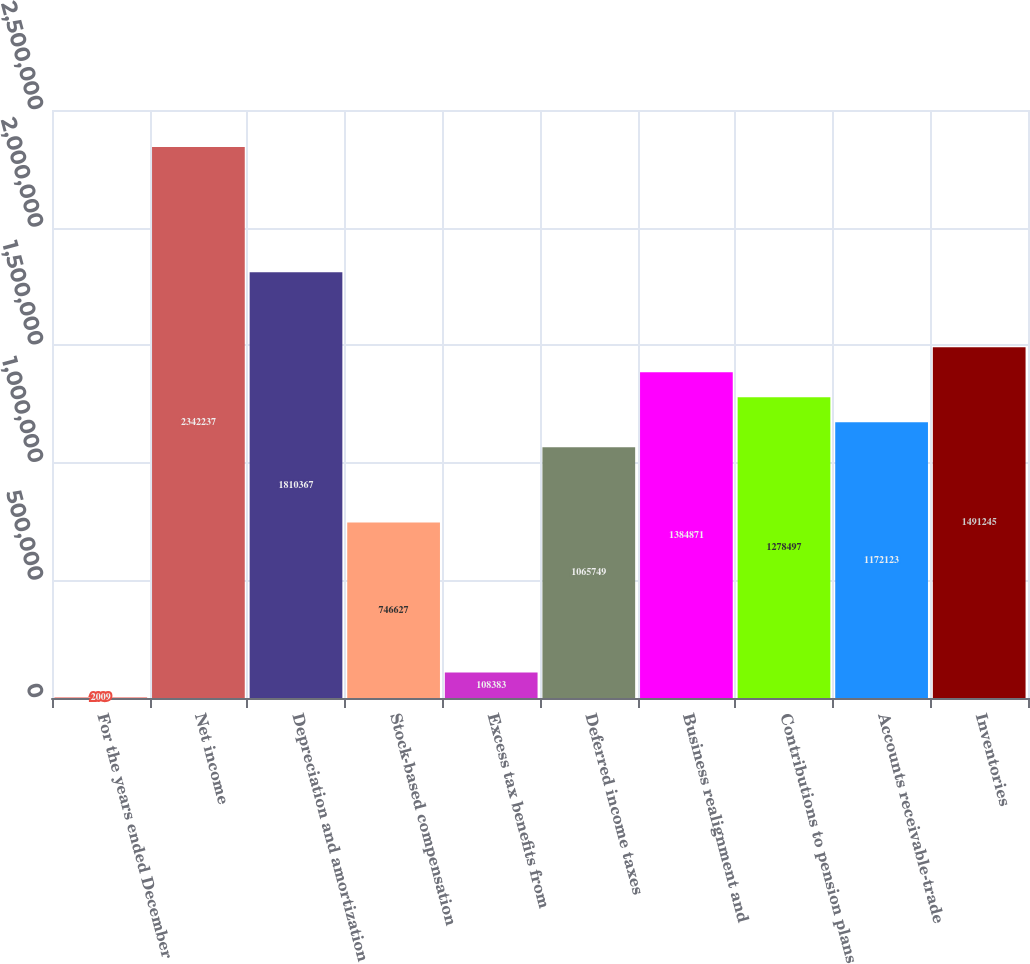Convert chart. <chart><loc_0><loc_0><loc_500><loc_500><bar_chart><fcel>For the years ended December<fcel>Net income<fcel>Depreciation and amortization<fcel>Stock-based compensation<fcel>Excess tax benefits from<fcel>Deferred income taxes<fcel>Business realignment and<fcel>Contributions to pension plans<fcel>Accounts receivable-trade<fcel>Inventories<nl><fcel>2009<fcel>2.34224e+06<fcel>1.81037e+06<fcel>746627<fcel>108383<fcel>1.06575e+06<fcel>1.38487e+06<fcel>1.2785e+06<fcel>1.17212e+06<fcel>1.49124e+06<nl></chart> 